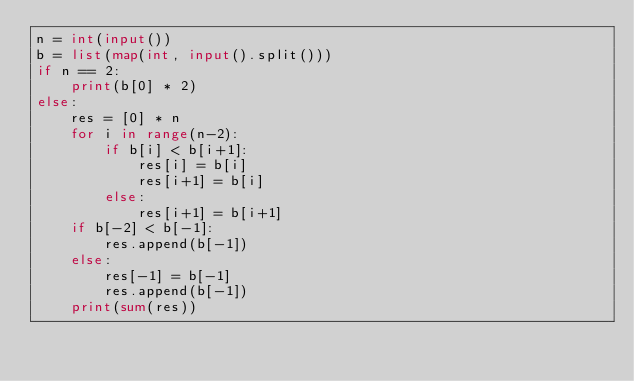<code> <loc_0><loc_0><loc_500><loc_500><_Python_>n = int(input())
b = list(map(int, input().split()))
if n == 2:
    print(b[0] * 2)
else:
    res = [0] * n
    for i in range(n-2):
        if b[i] < b[i+1]:
            res[i] = b[i]
            res[i+1] = b[i]
        else:
            res[i+1] = b[i+1]
    if b[-2] < b[-1]:
        res.append(b[-1])
    else:
        res[-1] = b[-1]
        res.append(b[-1])
    print(sum(res))
</code> 